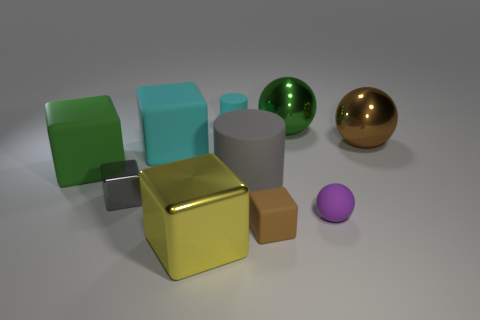There is a metal ball that is behind the brown object that is behind the big green thing on the left side of the cyan rubber block; what is its size?
Your response must be concise. Large. What is the color of the small rubber object that is the same shape as the big cyan rubber object?
Offer a terse response. Brown. Does the gray shiny block have the same size as the green sphere?
Your response must be concise. No. There is a green thing to the left of the cyan cylinder; what is its material?
Make the answer very short. Rubber. What number of other objects are the same shape as the small purple thing?
Offer a very short reply. 2. Is the tiny purple thing the same shape as the large cyan thing?
Provide a succinct answer. No. There is a tiny shiny thing; are there any small cyan rubber things in front of it?
Give a very brief answer. No. How many things are purple cubes or large green objects?
Your answer should be very brief. 2. How many other objects are there of the same size as the green cube?
Provide a short and direct response. 5. How many things are on the right side of the small cyan thing and behind the big brown metal thing?
Offer a very short reply. 1. 